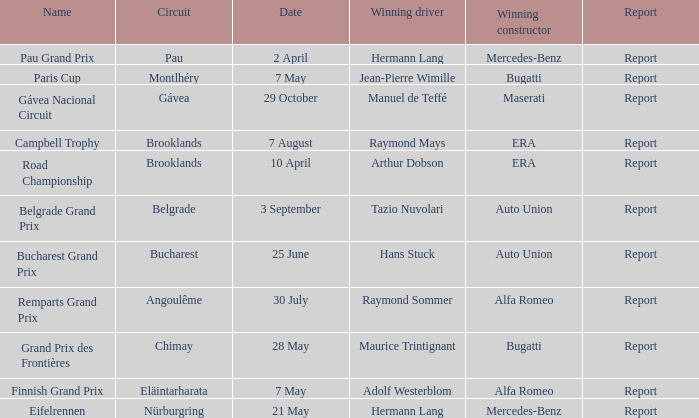Tell me the winning constructor for the paris cup Bugatti. 